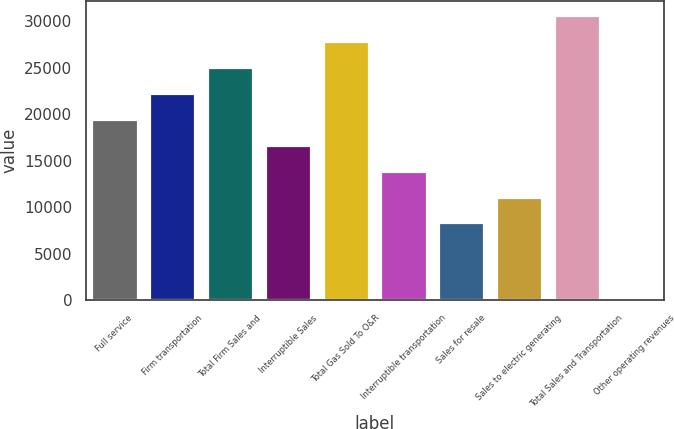Convert chart. <chart><loc_0><loc_0><loc_500><loc_500><bar_chart><fcel>Full service<fcel>Firm transportation<fcel>Total Firm Sales and<fcel>Interruptible Sales<fcel>Total Gas Sold To O&R<fcel>Interruptible transportation<fcel>Sales for resale<fcel>Sales to electric generating<fcel>Total Sales and Transportation<fcel>Other operating revenues<nl><fcel>19526.4<fcel>22314.6<fcel>25102.8<fcel>16738.2<fcel>27891<fcel>13950<fcel>8373.6<fcel>11161.8<fcel>30679.2<fcel>9<nl></chart> 